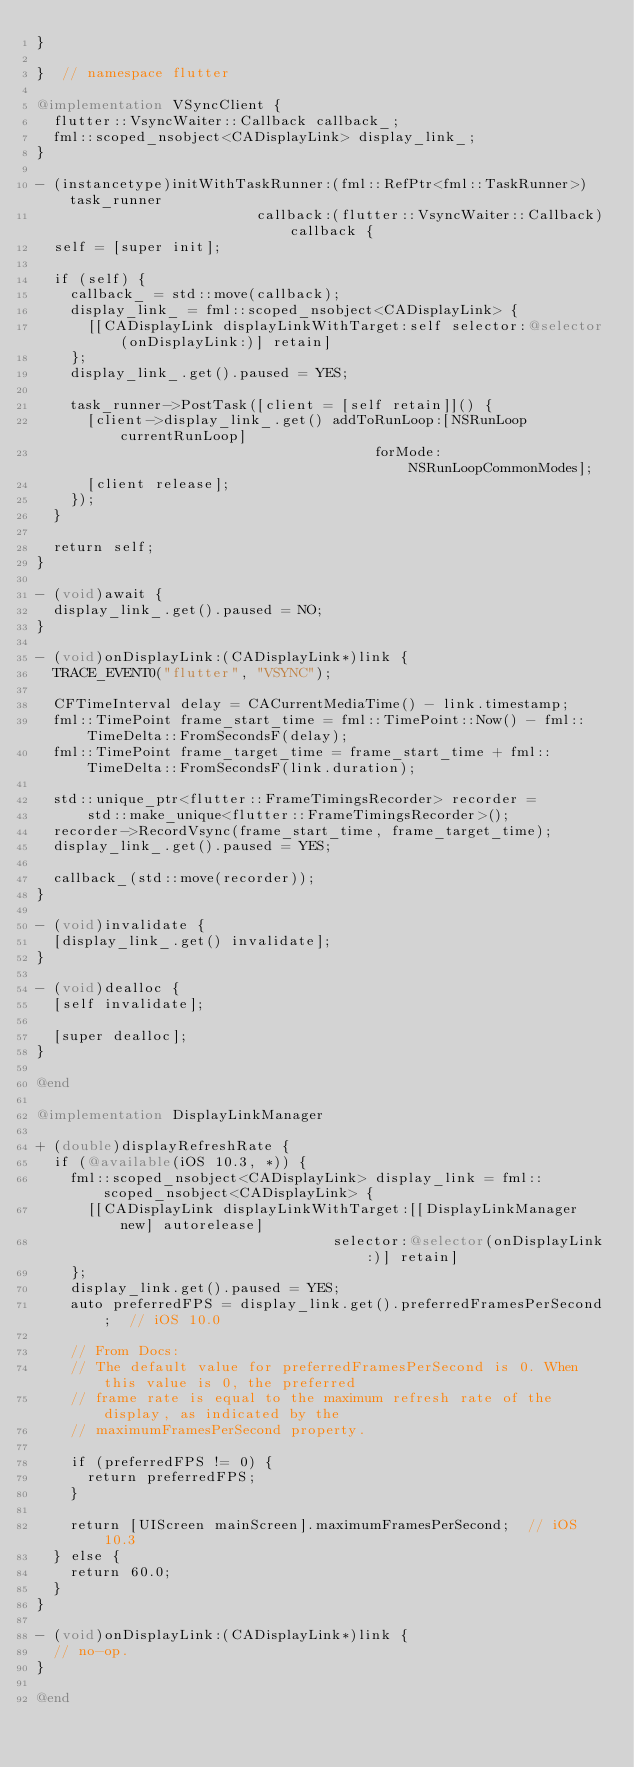Convert code to text. <code><loc_0><loc_0><loc_500><loc_500><_ObjectiveC_>}

}  // namespace flutter

@implementation VSyncClient {
  flutter::VsyncWaiter::Callback callback_;
  fml::scoped_nsobject<CADisplayLink> display_link_;
}

- (instancetype)initWithTaskRunner:(fml::RefPtr<fml::TaskRunner>)task_runner
                          callback:(flutter::VsyncWaiter::Callback)callback {
  self = [super init];

  if (self) {
    callback_ = std::move(callback);
    display_link_ = fml::scoped_nsobject<CADisplayLink> {
      [[CADisplayLink displayLinkWithTarget:self selector:@selector(onDisplayLink:)] retain]
    };
    display_link_.get().paused = YES;

    task_runner->PostTask([client = [self retain]]() {
      [client->display_link_.get() addToRunLoop:[NSRunLoop currentRunLoop]
                                        forMode:NSRunLoopCommonModes];
      [client release];
    });
  }

  return self;
}

- (void)await {
  display_link_.get().paused = NO;
}

- (void)onDisplayLink:(CADisplayLink*)link {
  TRACE_EVENT0("flutter", "VSYNC");

  CFTimeInterval delay = CACurrentMediaTime() - link.timestamp;
  fml::TimePoint frame_start_time = fml::TimePoint::Now() - fml::TimeDelta::FromSecondsF(delay);
  fml::TimePoint frame_target_time = frame_start_time + fml::TimeDelta::FromSecondsF(link.duration);

  std::unique_ptr<flutter::FrameTimingsRecorder> recorder =
      std::make_unique<flutter::FrameTimingsRecorder>();
  recorder->RecordVsync(frame_start_time, frame_target_time);
  display_link_.get().paused = YES;

  callback_(std::move(recorder));
}

- (void)invalidate {
  [display_link_.get() invalidate];
}

- (void)dealloc {
  [self invalidate];

  [super dealloc];
}

@end

@implementation DisplayLinkManager

+ (double)displayRefreshRate {
  if (@available(iOS 10.3, *)) {
    fml::scoped_nsobject<CADisplayLink> display_link = fml::scoped_nsobject<CADisplayLink> {
      [[CADisplayLink displayLinkWithTarget:[[DisplayLinkManager new] autorelease]
                                   selector:@selector(onDisplayLink:)] retain]
    };
    display_link.get().paused = YES;
    auto preferredFPS = display_link.get().preferredFramesPerSecond;  // iOS 10.0

    // From Docs:
    // The default value for preferredFramesPerSecond is 0. When this value is 0, the preferred
    // frame rate is equal to the maximum refresh rate of the display, as indicated by the
    // maximumFramesPerSecond property.

    if (preferredFPS != 0) {
      return preferredFPS;
    }

    return [UIScreen mainScreen].maximumFramesPerSecond;  // iOS 10.3
  } else {
    return 60.0;
  }
}

- (void)onDisplayLink:(CADisplayLink*)link {
  // no-op.
}

@end
</code> 